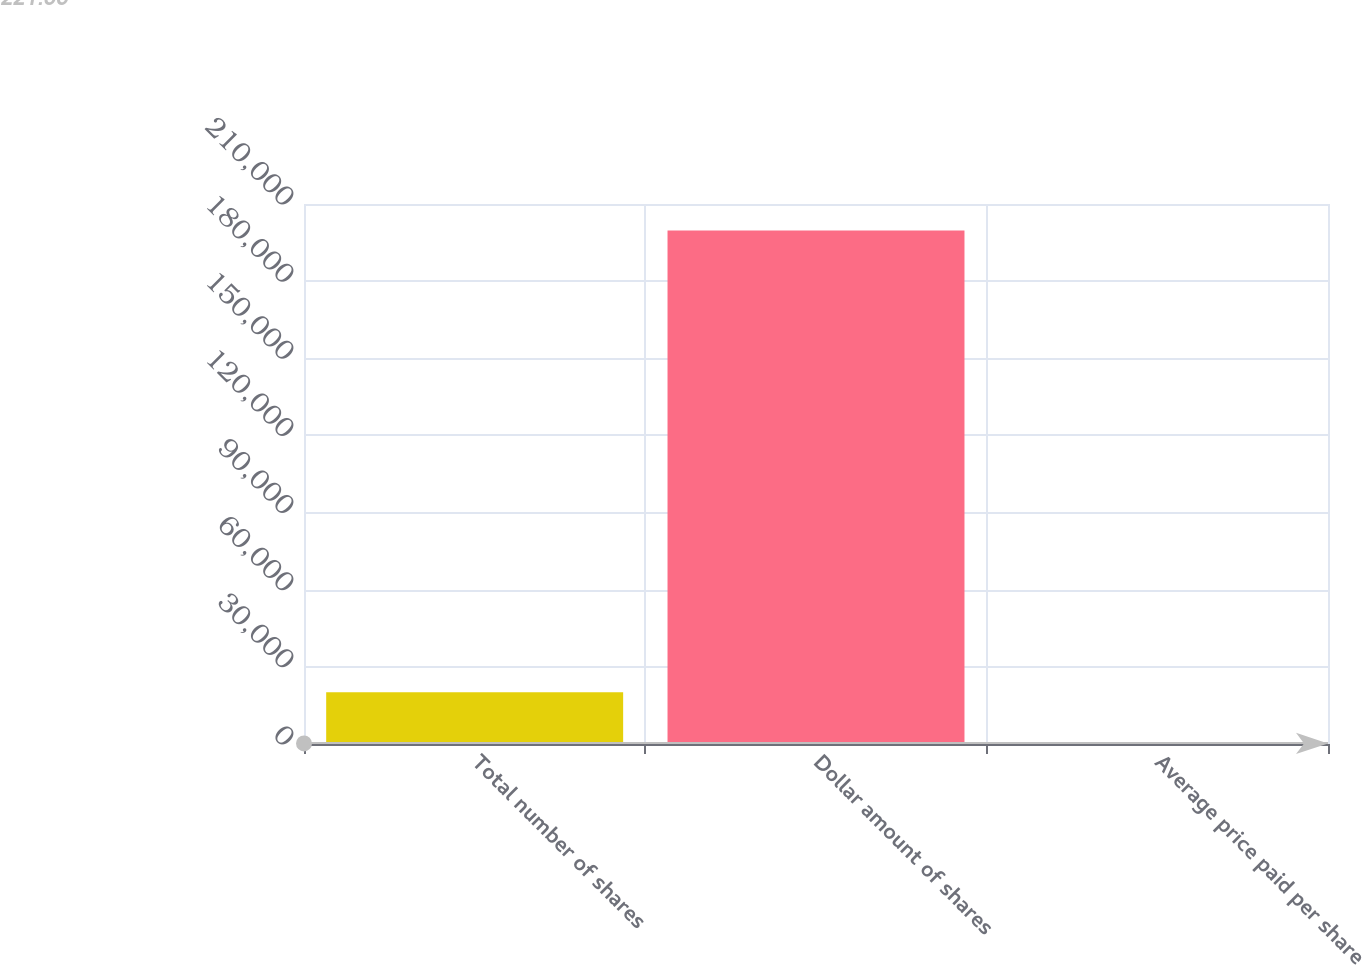<chart> <loc_0><loc_0><loc_500><loc_500><bar_chart><fcel>Total number of shares<fcel>Dollar amount of shares<fcel>Average price paid per share<nl><fcel>20166.3<fcel>199666<fcel>221.88<nl></chart> 